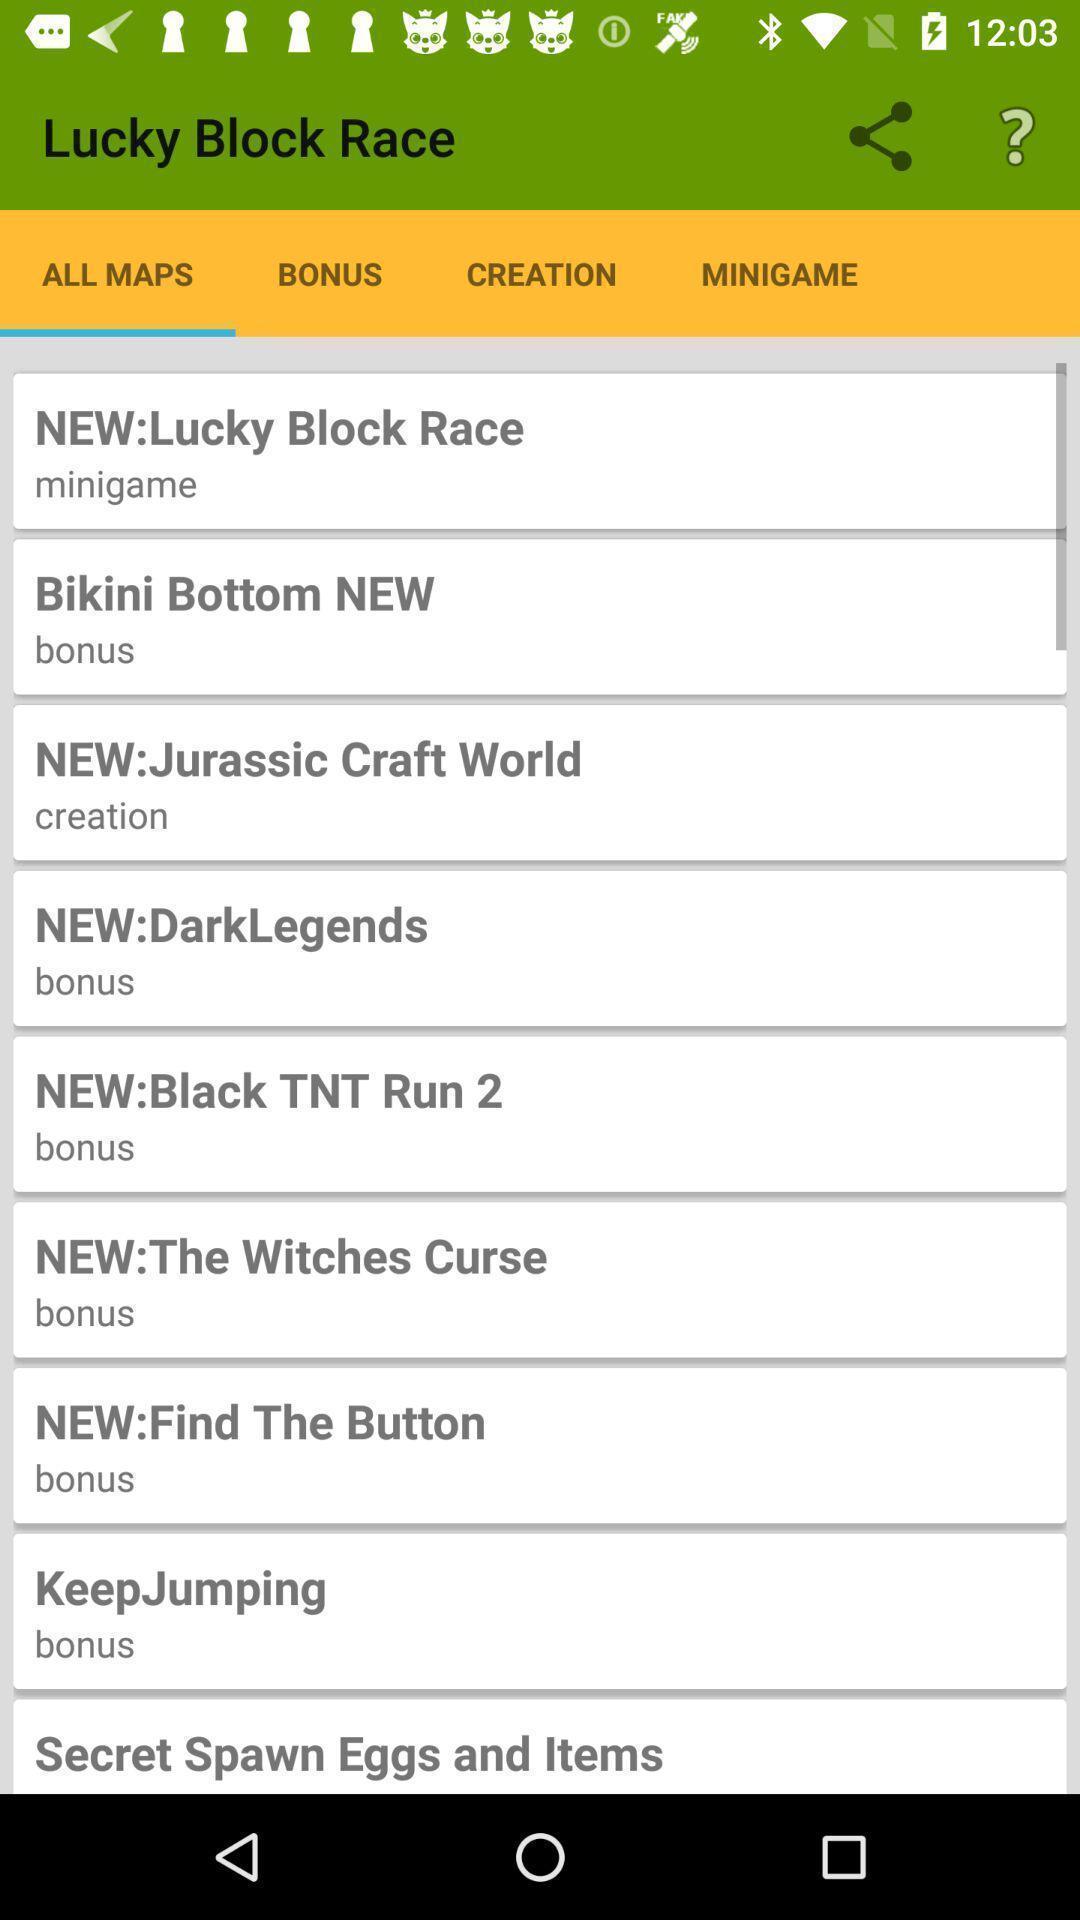Describe the key features of this screenshot. Page displaying various maps. 